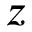Convert formula to latex. <formula><loc_0><loc_0><loc_500><loc_500>z</formula> 